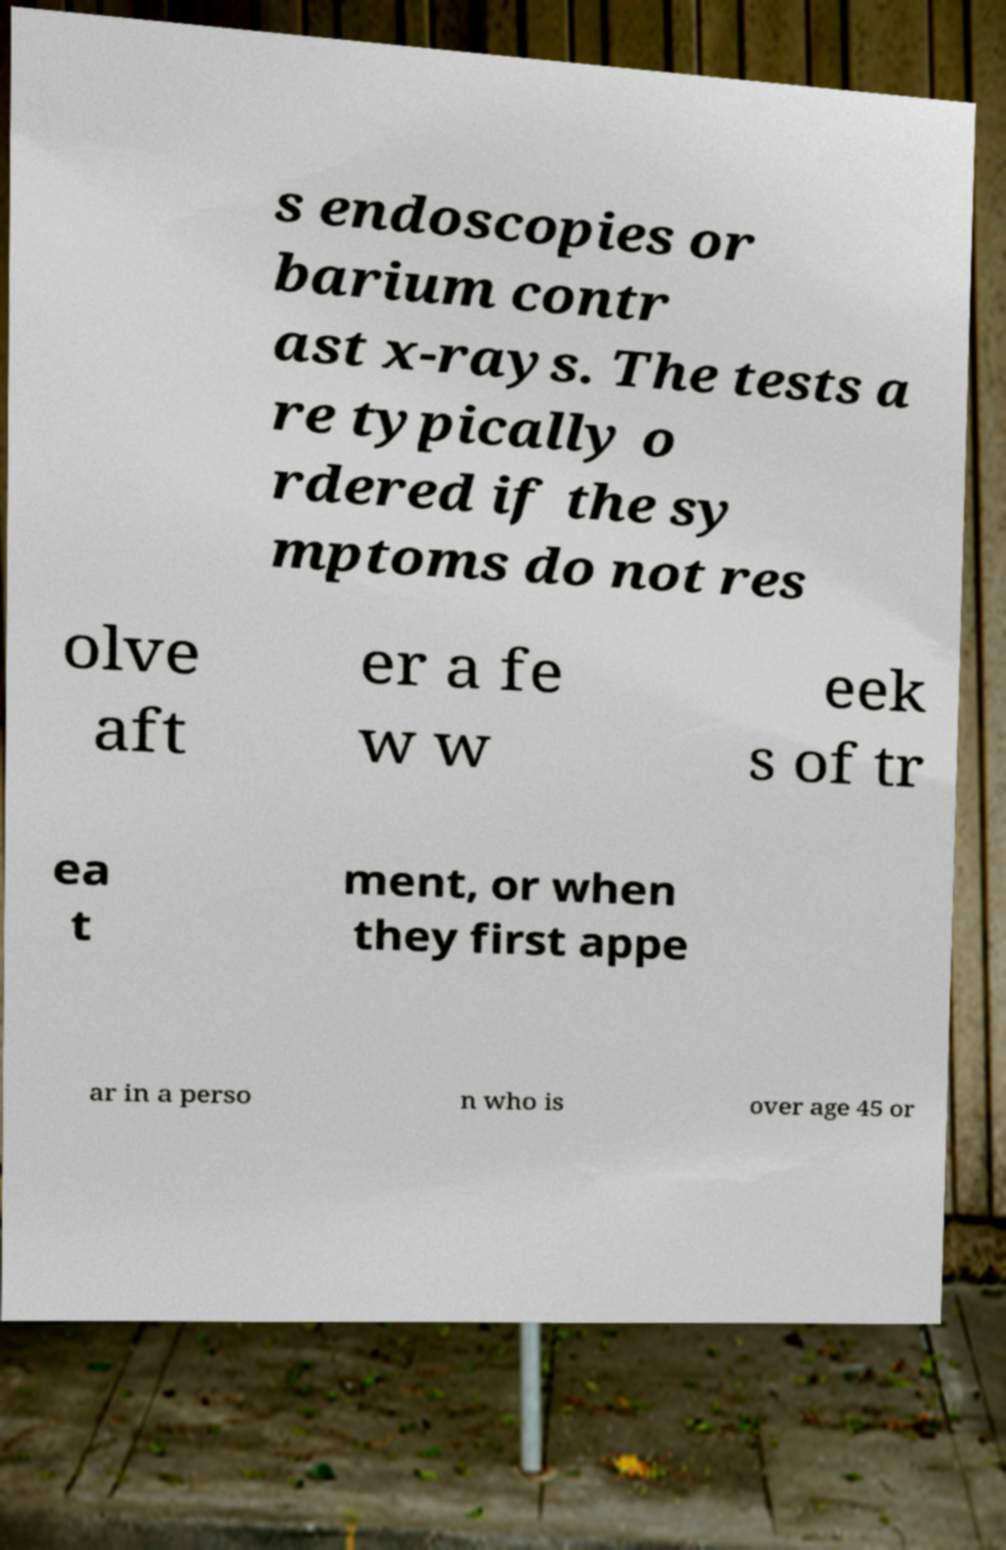Could you assist in decoding the text presented in this image and type it out clearly? s endoscopies or barium contr ast x-rays. The tests a re typically o rdered if the sy mptoms do not res olve aft er a fe w w eek s of tr ea t ment, or when they first appe ar in a perso n who is over age 45 or 